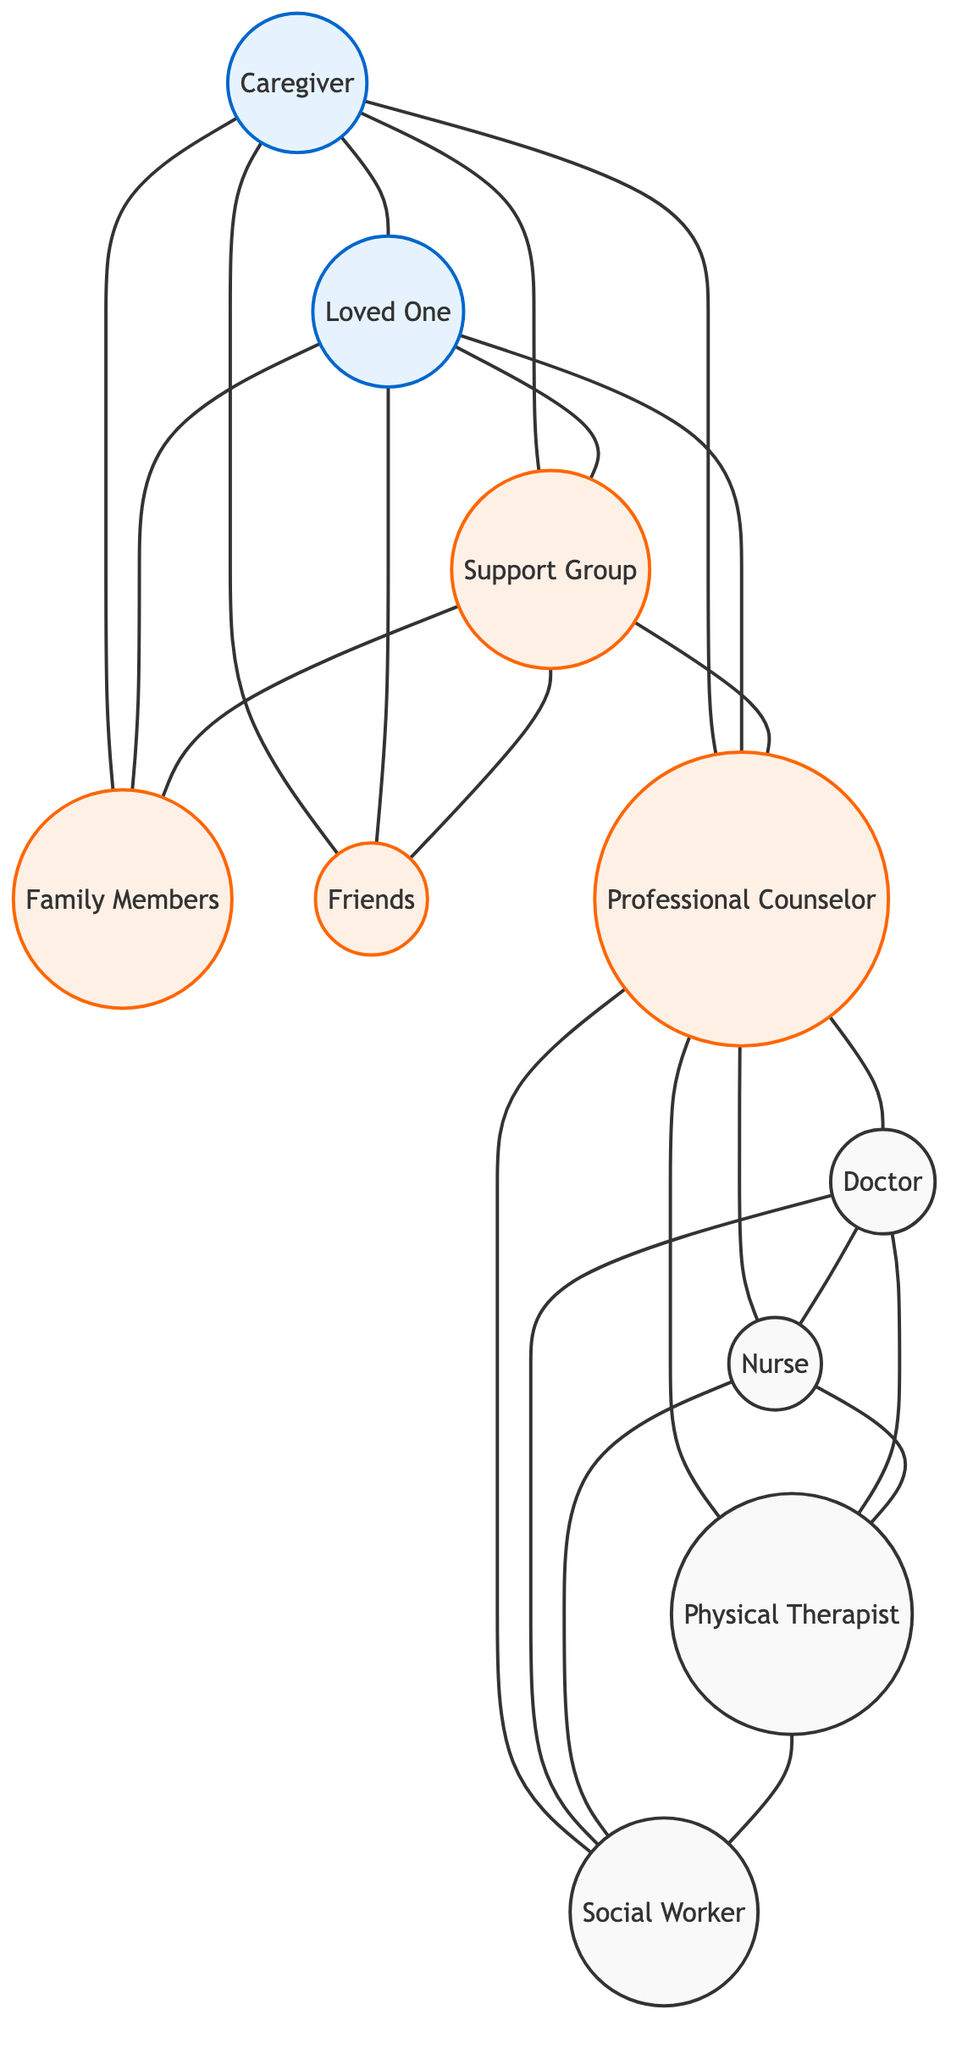What nodes are present in the diagram? The diagram lists ten nodes representing important people in the emotional support network: Caregiver, Loved One, Family Members, Friends, Support Group, Professional Counselor, Doctor, Nurse, Physical Therapist, and Social Worker.
Answer: Ten nodes How many edges connect Family Members? The Family Members node is connected to four nodes: Caregiver, Loved One, Support Group, and Friends. Thus, there are four edges.
Answer: Four edges What is the relationship between the Caregiver and the Loved One? The diagram shows a direct connection (edge) between the Caregiver and the Loved One, indicating a supportive relationship.
Answer: Direct connection Which node connects the most nodes? The Professional Counselor node connects to five other nodes: Caregiver, Loved One, Support Group, Doctor, Nurse, Physical Therapist, and Social Worker. This is the greatest number of connections.
Answer: Professional Counselor How many different roles can Professional Counselor connect to? The Professional Counselor connects to four distinct roles: Doctor, Nurse, Physical Therapist, and Social Worker.
Answer: Four roles What is the least connected node? The Doctor, while connected to four other nodes, has no direct connection to the Caregiver or Loved One. This makes it less connected than others.
Answer: Doctor What nodes are indirectly connected through the Support Group? The Support Group indirectly connects to the Loved One, Family Members, Friends, and Professional Counselor through edges that lead to these nodes. This means that anyone connected can provide emotional support through the Support Group.
Answer: Loved One, Family Members, Friends, Professional Counselor Which two nodes share the most connections? The Professional Counselor and Support Group share the most connections as each connects to four other nodes, hence forming a network of support.
Answer: Professional Counselor, Support Group How does the relationship between Friends and the Support Group impact emotional support? The Friends connect with both the Caregiver and the Loved One via edges, and they also link to the Support Group. This indicates a network of support that can enhance emotional assistance, making the relationship significant in providing a community support network.
Answer: Friends, Support Group 